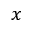<formula> <loc_0><loc_0><loc_500><loc_500>x</formula> 